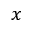<formula> <loc_0><loc_0><loc_500><loc_500>x</formula> 